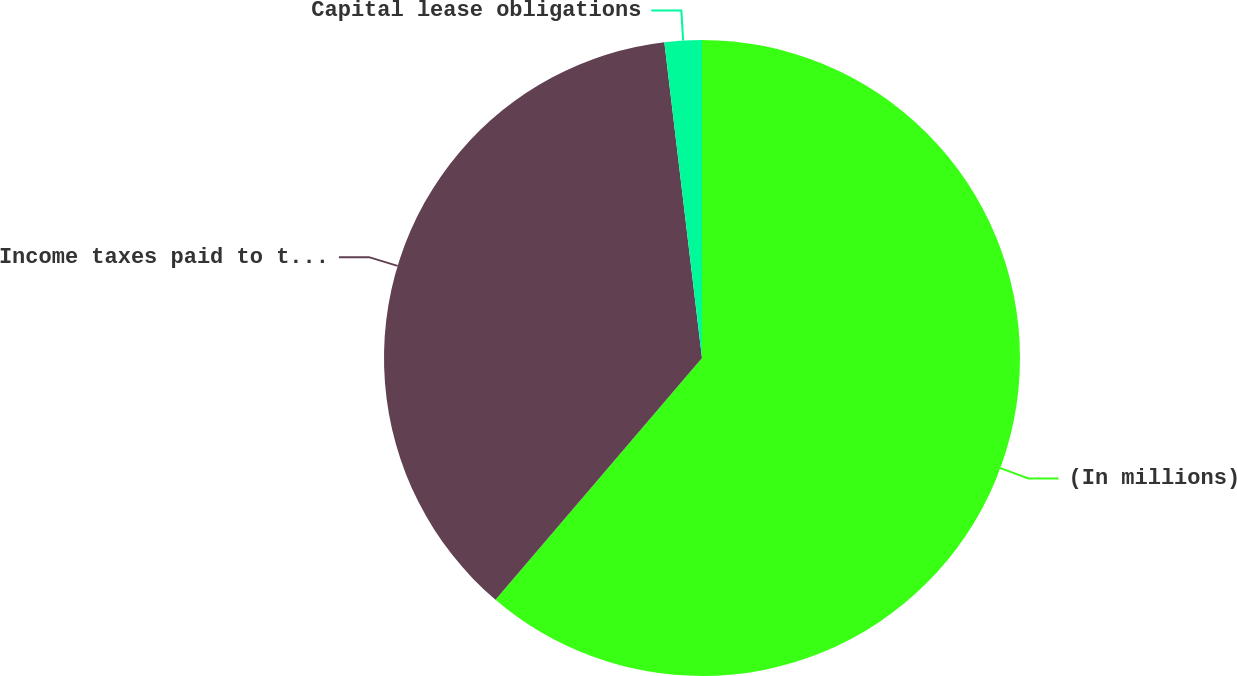<chart> <loc_0><loc_0><loc_500><loc_500><pie_chart><fcel>(In millions)<fcel>Income taxes paid to taxing<fcel>Capital lease obligations<nl><fcel>61.25%<fcel>36.86%<fcel>1.89%<nl></chart> 